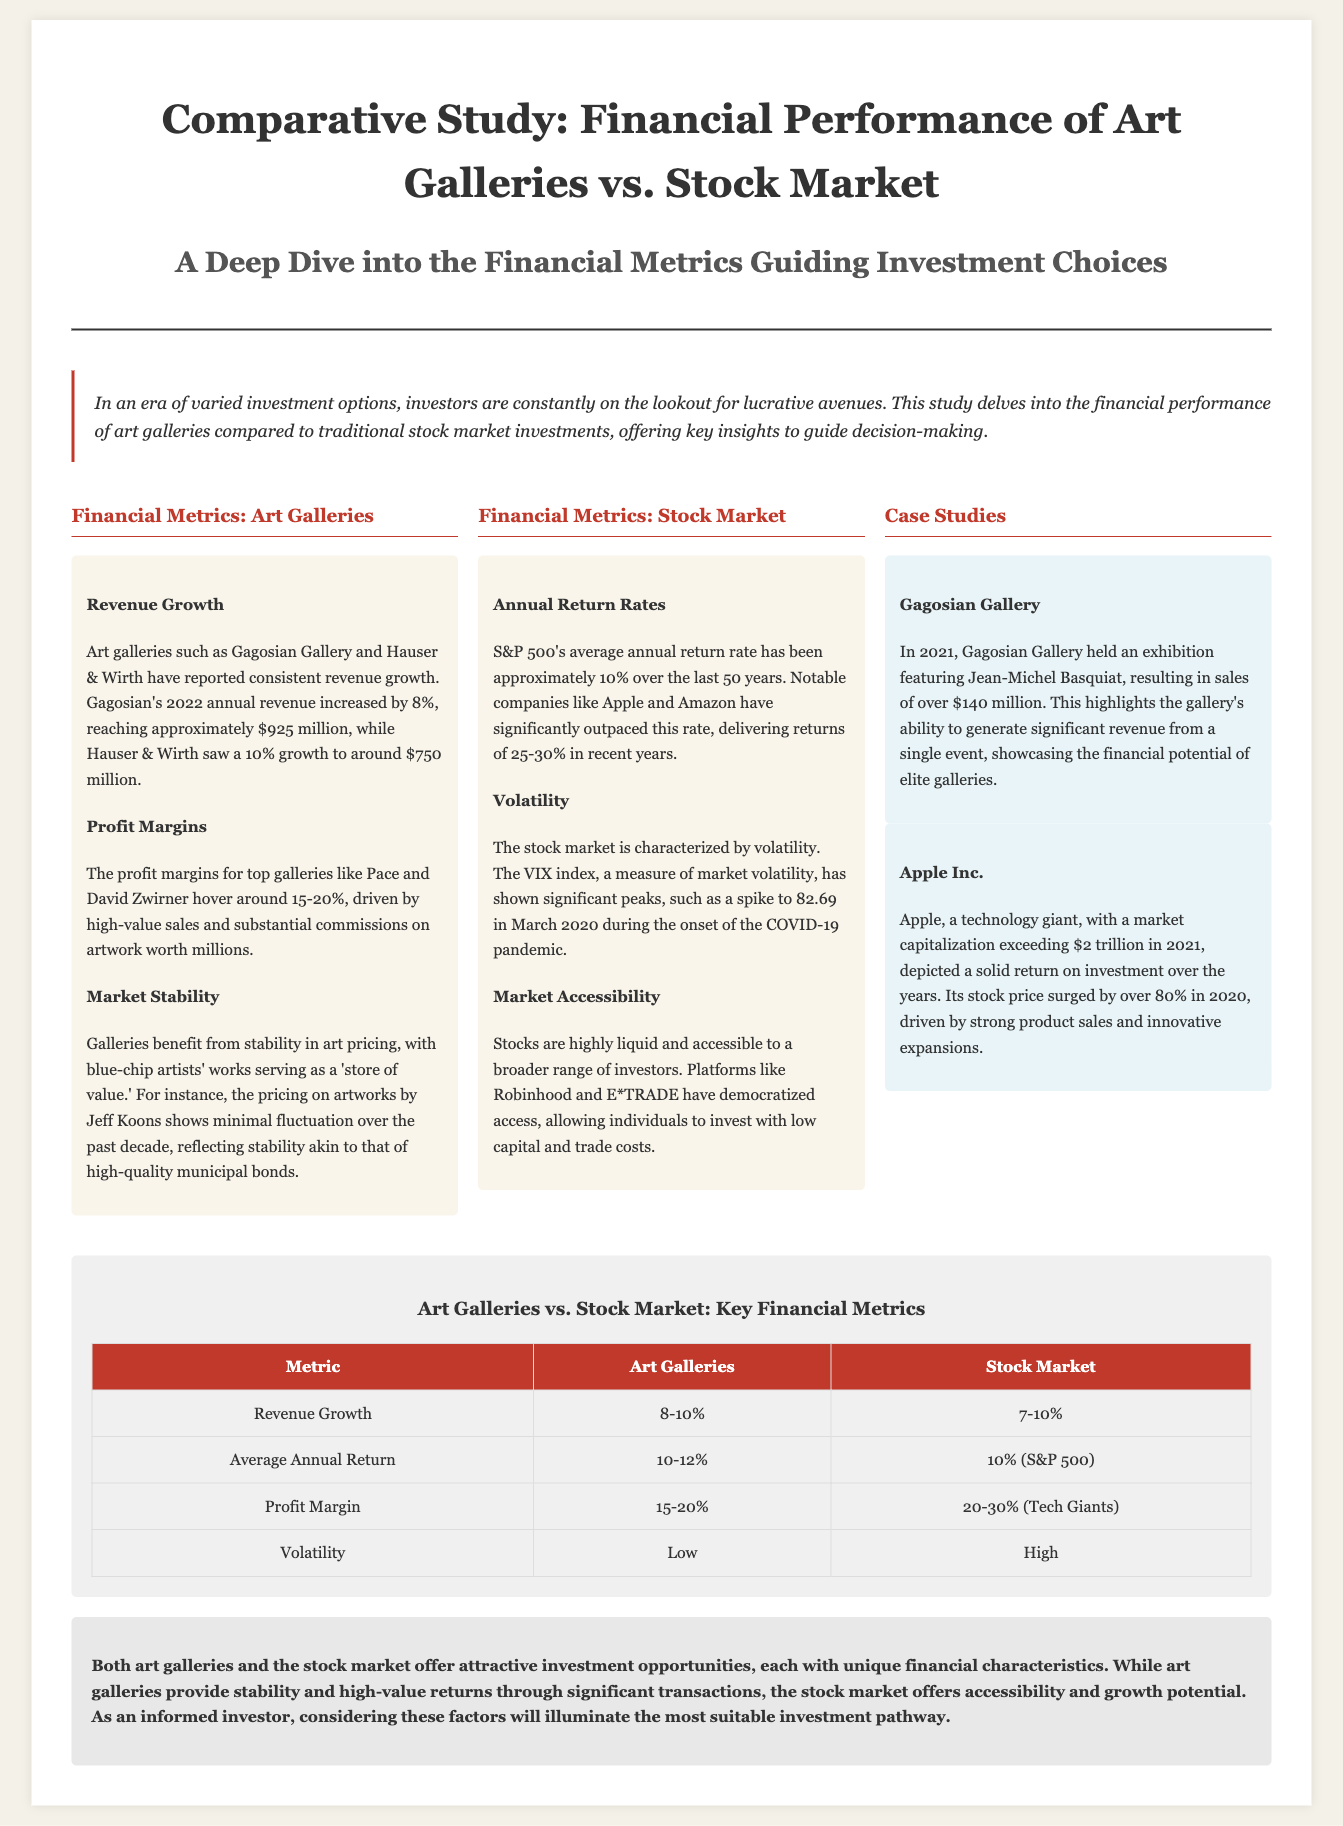What was Gagosian Gallery's revenue growth in 2022? Gagosian Gallery reported an 8% revenue growth in 2022, reaching approximately $925 million.
Answer: 8% What are the profit margins for top galleries like Pace and David Zwirner? The profit margins for top galleries hover around 15-20%, driven by high-value sales and commissions.
Answer: 15-20% What is the average annual return rate of the S&P 500 over the last 50 years? The S&P 500's average annual return rate has been approximately 10% over the last 50 years.
Answer: 10% What significant event took place at Gagosian Gallery in 2021? The significant event was an exhibition featuring Jean-Michel Basquiat, resulting in sales of over $140 million.
Answer: $140 million Which company saw its stock price surge by over 80% in 2020? Apple Inc. depicted a solid return on investment over the years, with its stock price surging by over 80% in 2020.
Answer: Apple Inc What metric represents the volatility comparison between art galleries and the stock market? The document states that art galleries have low volatility while the stock market is characterized by high volatility.
Answer: Low / High What is the highest metric value listed for profit margins in the stock market? The profit margin for tech giants in the stock market ranges from 20-30%.
Answer: 30% How are stocks described in terms of investor accessibility? Stocks are described as highly liquid and accessible to a broader range of investors.
Answer: Highly liquid and accessible What is the title of this comparative study? The title of the comparative study is "Comparative Study: Financial Performance of Art Galleries vs. Stock Market."
Answer: Comparative Study: Financial Performance of Art Galleries vs. Stock Market 